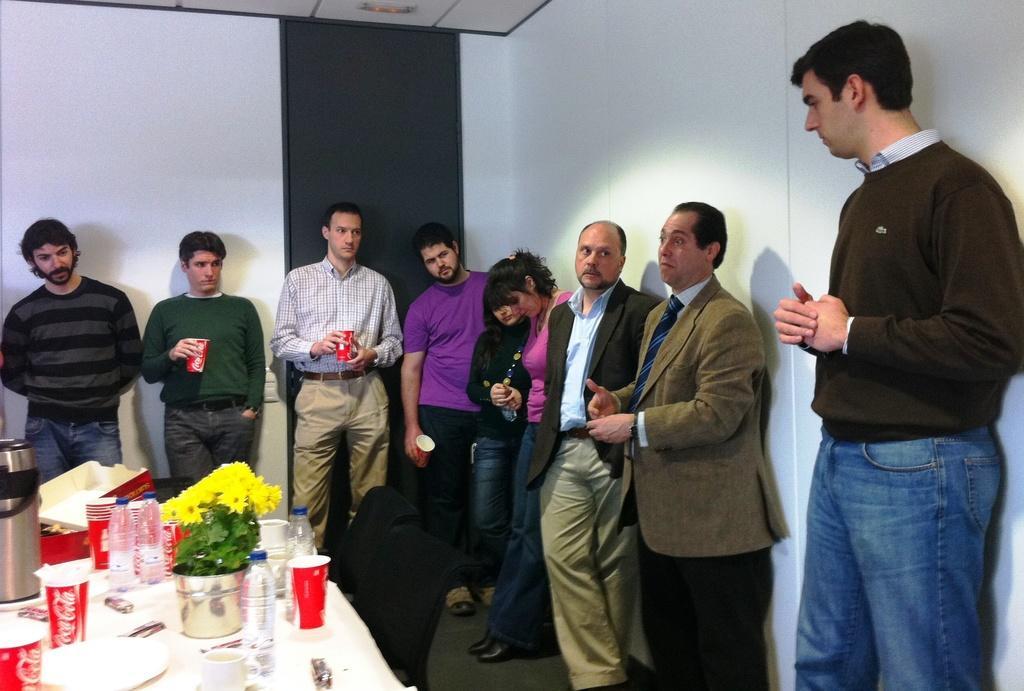How would you summarize this image in a sentence or two? The picture is taken inside a room. In the middle of the picture we can see many people standing. Towards left there is a table, on the table there are cups, bottle, flower pot, flowers, plant, pizza box, cup, plate and various objects. In the background it is wall and there is a door also. At the top it is ceiling. 